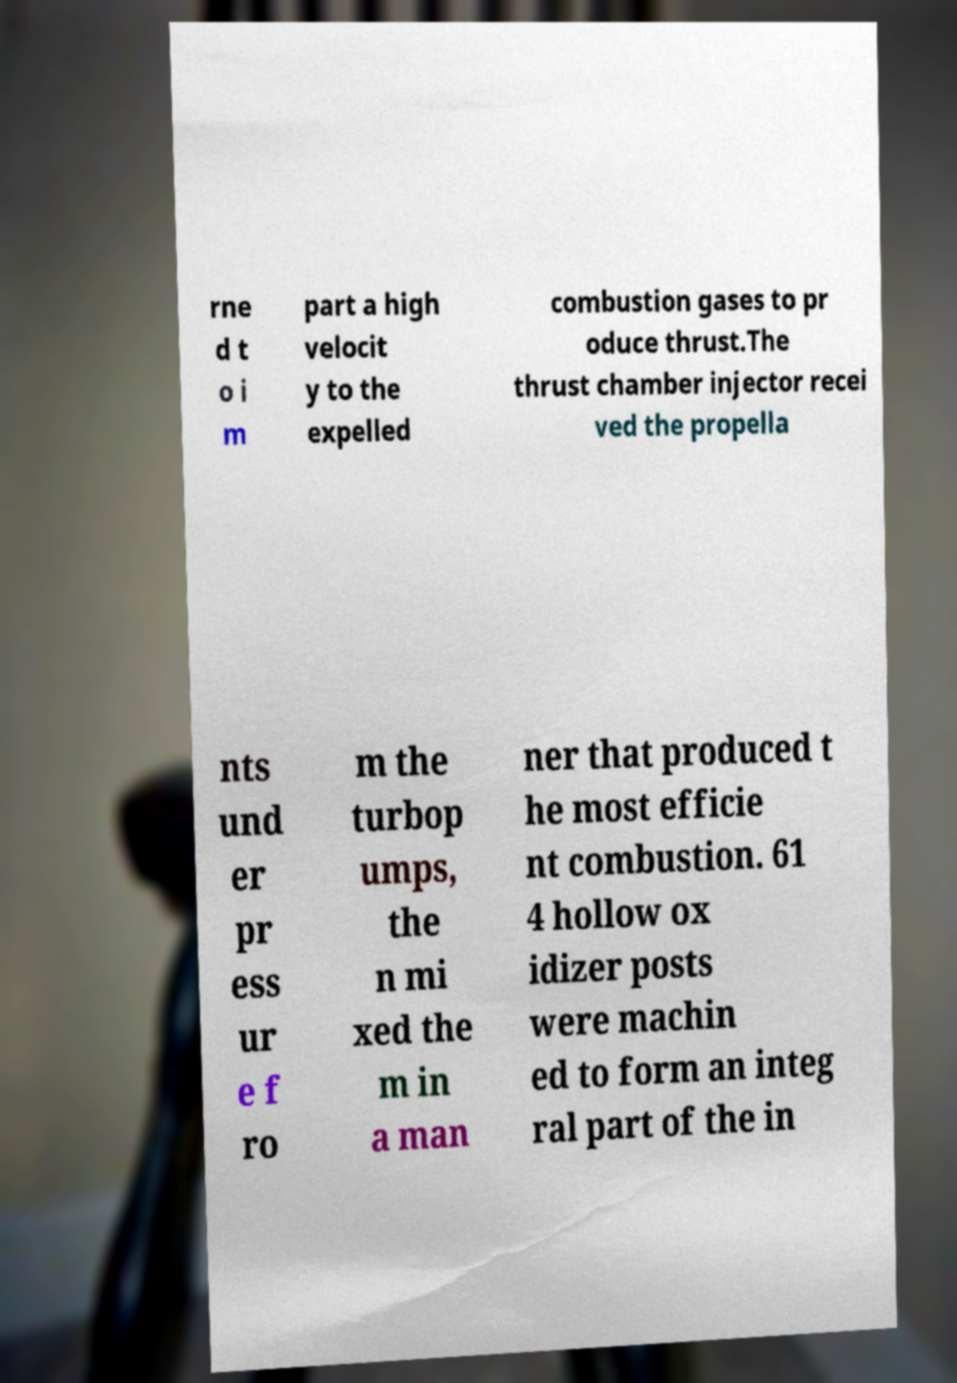Please identify and transcribe the text found in this image. rne d t o i m part a high velocit y to the expelled combustion gases to pr oduce thrust.The thrust chamber injector recei ved the propella nts und er pr ess ur e f ro m the turbop umps, the n mi xed the m in a man ner that produced t he most efficie nt combustion. 61 4 hollow ox idizer posts were machin ed to form an integ ral part of the in 